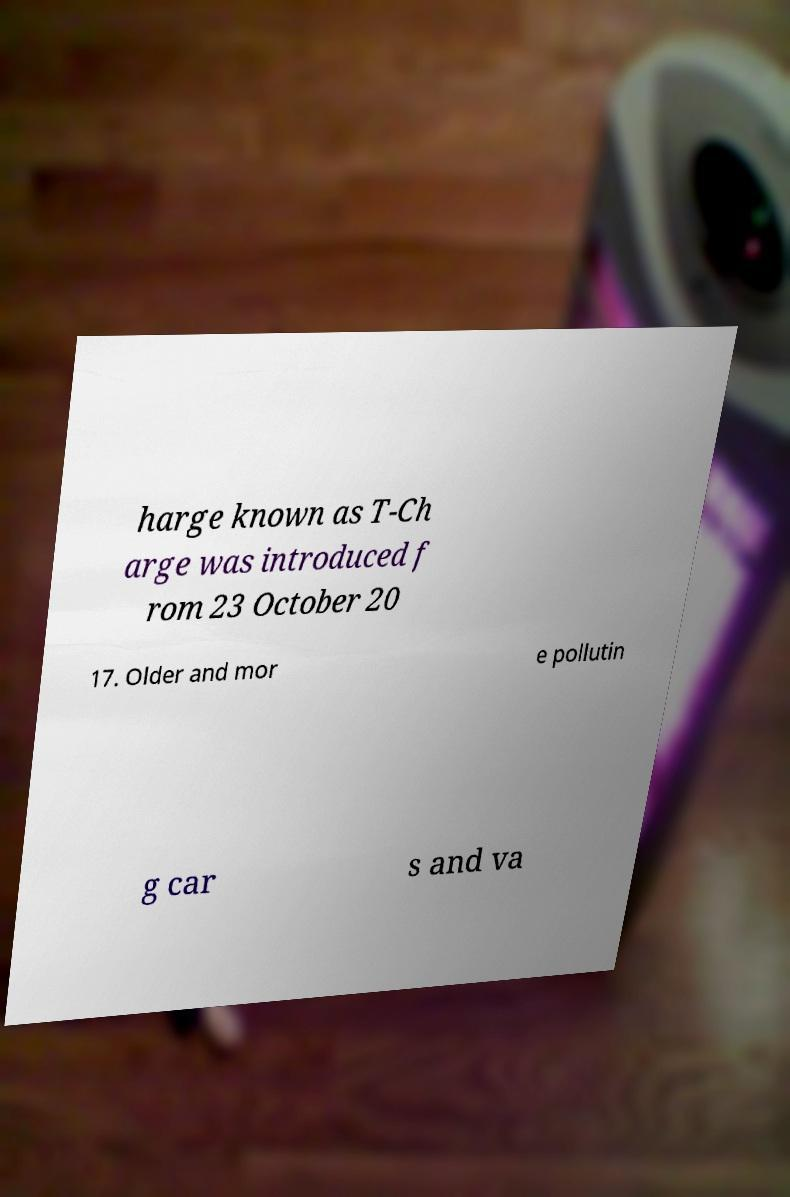Please identify and transcribe the text found in this image. harge known as T-Ch arge was introduced f rom 23 October 20 17. Older and mor e pollutin g car s and va 